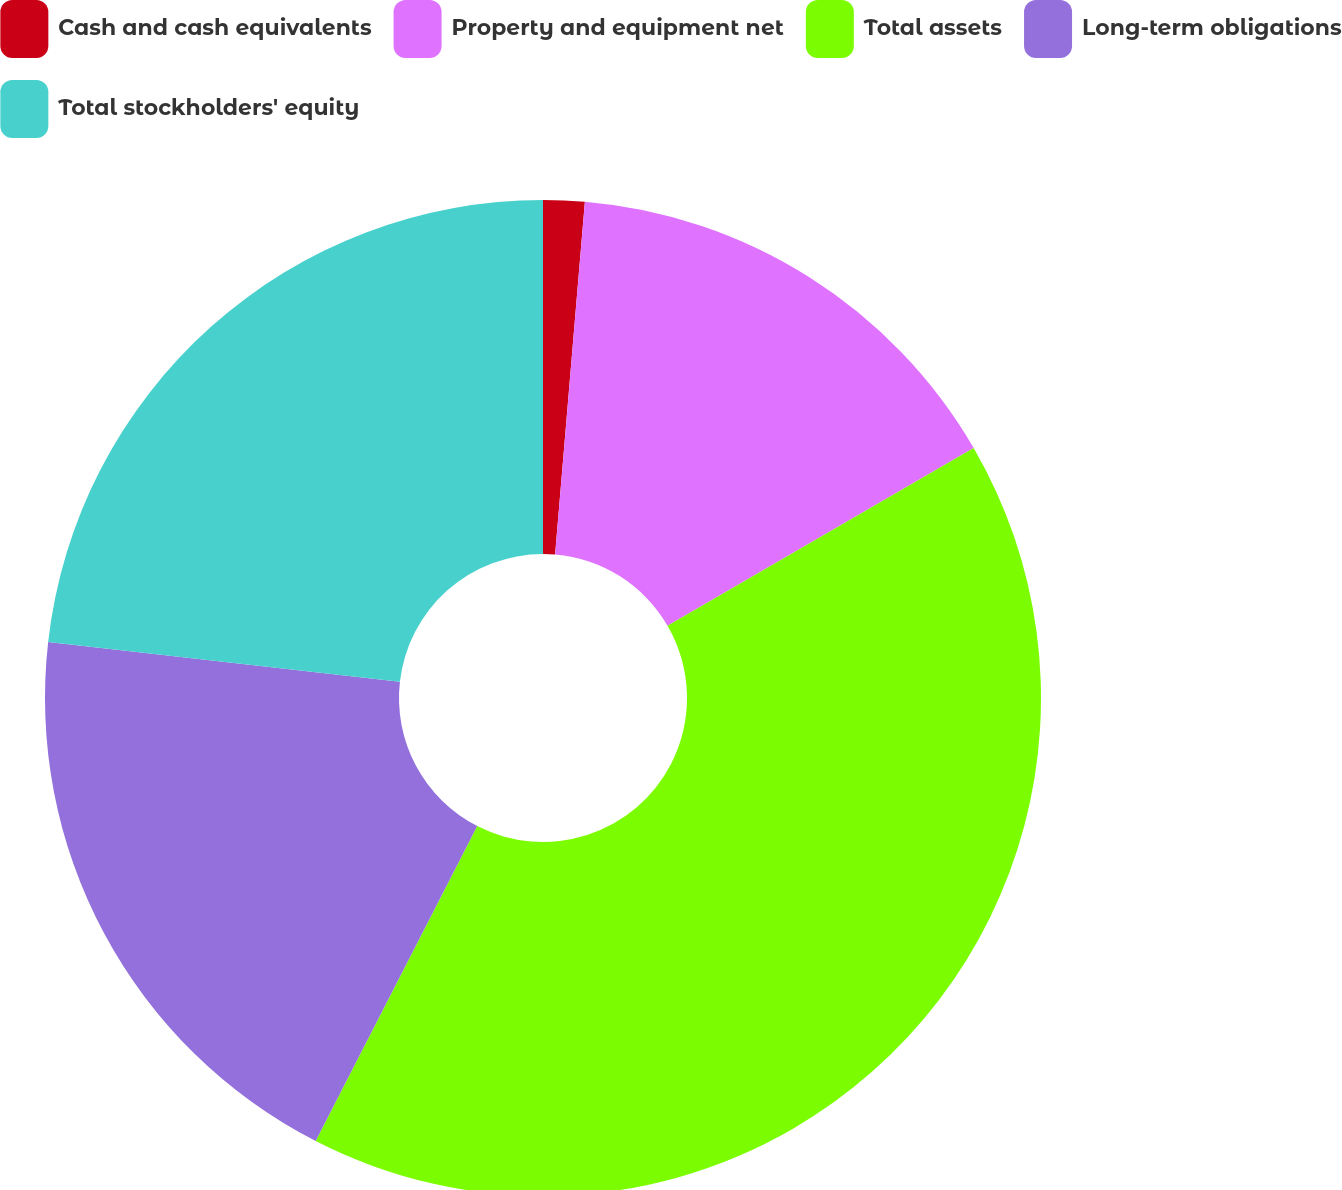Convert chart. <chart><loc_0><loc_0><loc_500><loc_500><pie_chart><fcel>Cash and cash equivalents<fcel>Property and equipment net<fcel>Total assets<fcel>Long-term obligations<fcel>Total stockholders' equity<nl><fcel>1.34%<fcel>15.29%<fcel>40.92%<fcel>19.25%<fcel>23.21%<nl></chart> 